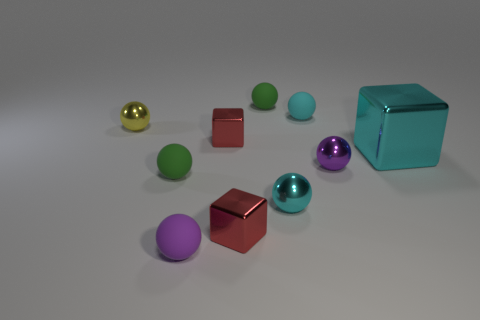Subtract all small green spheres. How many spheres are left? 5 Subtract all green balls. How many balls are left? 5 Subtract all green spheres. Subtract all gray blocks. How many spheres are left? 5 Subtract all balls. How many objects are left? 3 Add 7 metal spheres. How many metal spheres are left? 10 Add 5 tiny cyan metal objects. How many tiny cyan metal objects exist? 6 Subtract 1 cyan cubes. How many objects are left? 9 Subtract all cyan metallic objects. Subtract all small cyan rubber spheres. How many objects are left? 7 